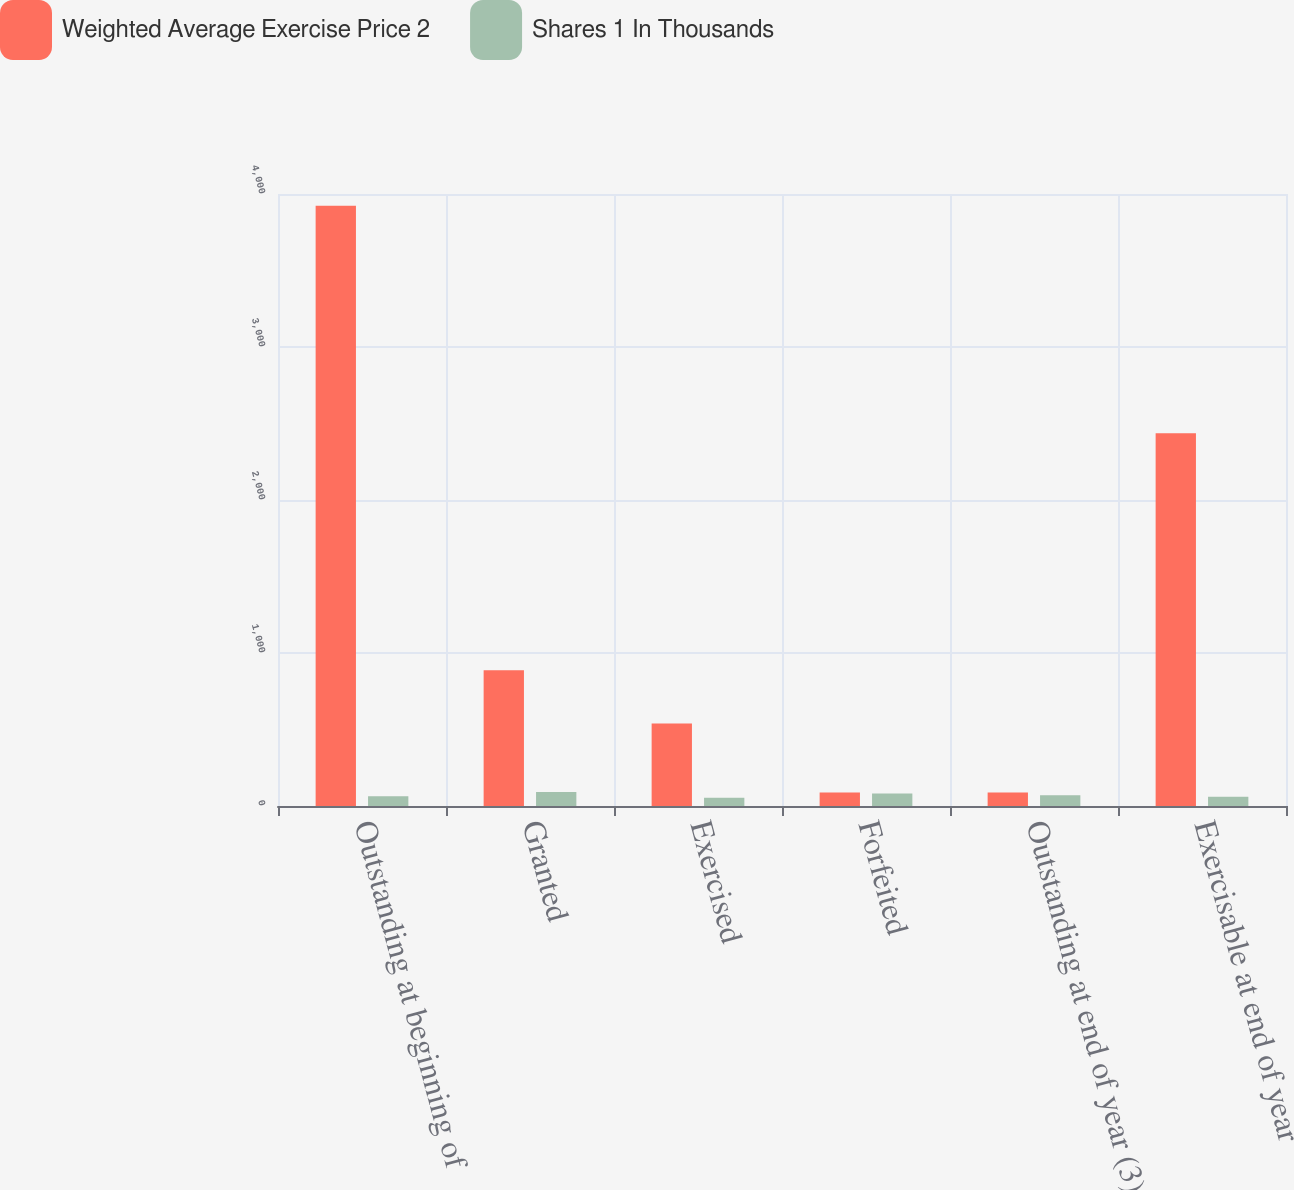<chart> <loc_0><loc_0><loc_500><loc_500><stacked_bar_chart><ecel><fcel>Outstanding at beginning of<fcel>Granted<fcel>Exercised<fcel>Forfeited<fcel>Outstanding at end of year (3)<fcel>Exercisable at end of year<nl><fcel>Weighted Average Exercise Price 2<fcel>3923<fcel>887<fcel>540<fcel>89<fcel>89<fcel>2437<nl><fcel>Shares 1 In Thousands<fcel>64<fcel>92<fcel>54<fcel>81<fcel>71<fcel>61<nl></chart> 